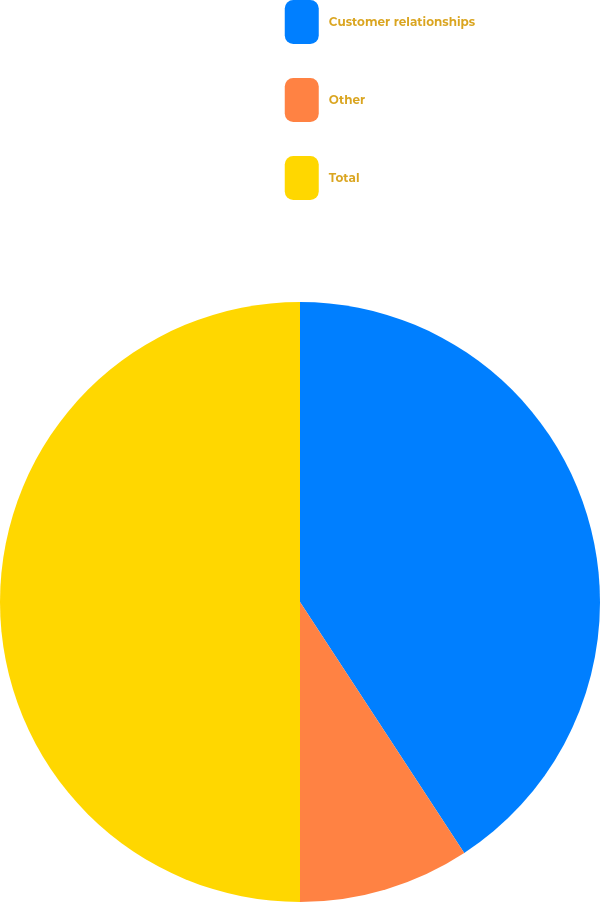Convert chart. <chart><loc_0><loc_0><loc_500><loc_500><pie_chart><fcel>Customer relationships<fcel>Other<fcel>Total<nl><fcel>40.78%<fcel>9.22%<fcel>50.0%<nl></chart> 